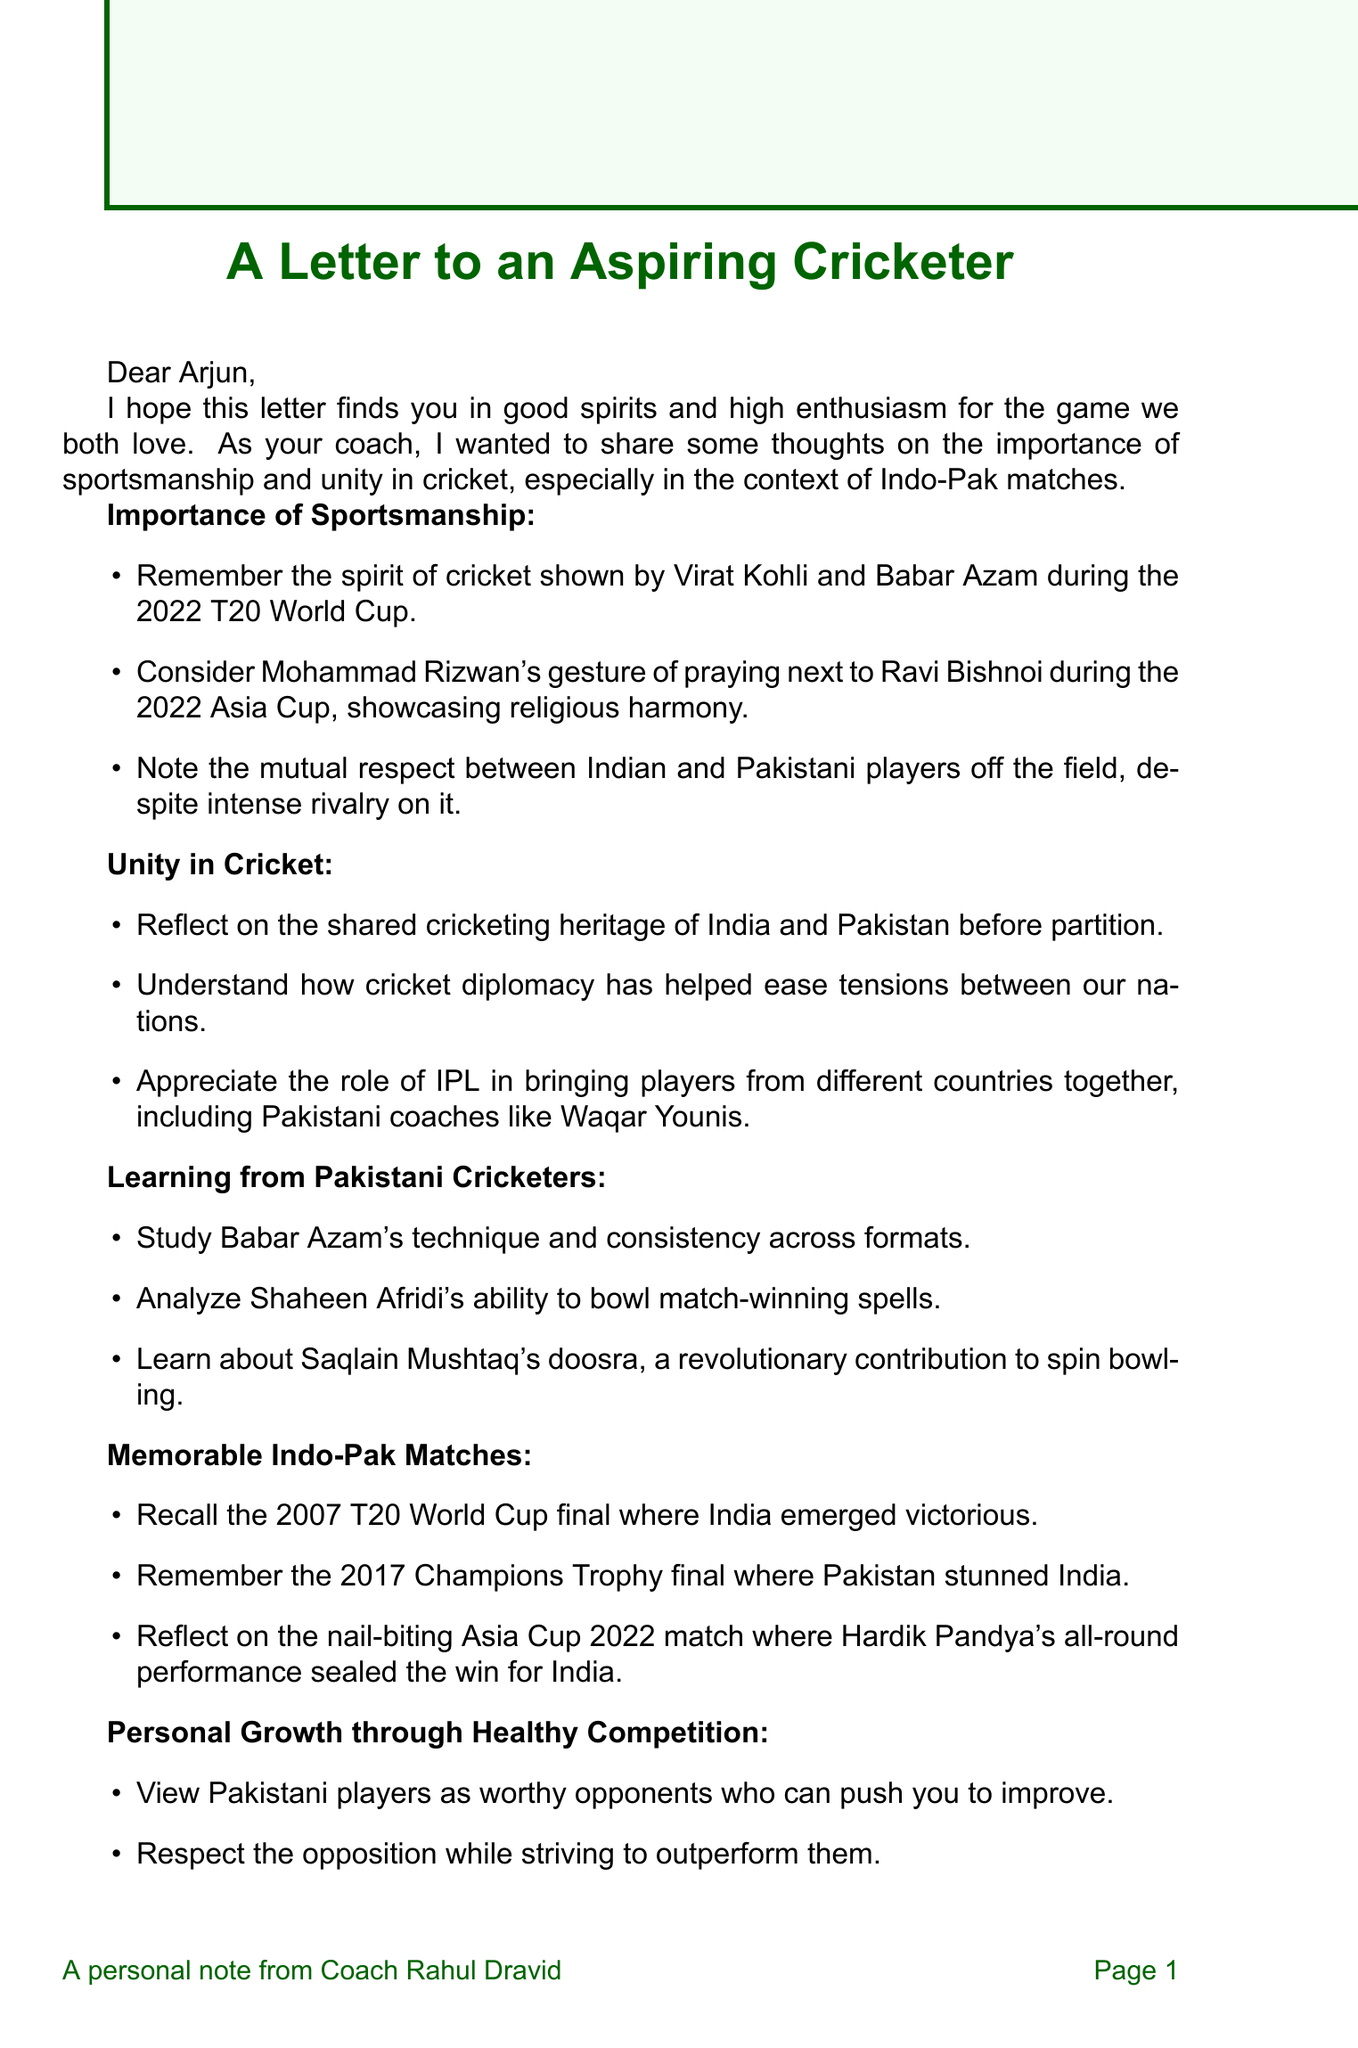What is the name of the coach? The letter identifies the coach as Rahul Dravid, who is addressing the player Arjun.
Answer: Rahul Dravid Who is the recipient of the letter? The letter is specifically addressed to a young cricketer named Arjun, indicating he is the recipient.
Answer: Arjun What year did the T20 World Cup mentioned in the letter take place? The letter references the 2022 T20 World Cup, highlighting its significance in sportsmanship between Indian and Pakistani players.
Answer: 2022 Which Pakistani cricketer's bowling technique is praised in the letter? The letter highlights Shaheen Afridi's ability to bowl match-winning spells, making a note of his impressive skills.
Answer: Shaheen Afridi What event did India win in 2007? The letter recalls the 2007 T20 World Cup final, where India emerged victorious against Pakistan, marking a memorable match.
Answer: T20 World Cup final What does the coach encourage Arjun to embody? The coach urges Arjun to embody the spirit of cricket in all his actions, fostering good sportsmanship and behavior.
Answer: spirit of cricket Which Pakistani coach is mentioned in connection with the IPL? The letter mentions Waqar Younis as a notable Pakistani coach who has been involved in the IPL, promoting unity through cricket.
Answer: Waqar Younis How does the coach suggest Arjun should view Pakistani players? The coach encourages Arjun to view Pakistani players as worthy opponents that can inspire him to improve his own game.
Answer: worthy opponents What gesture did Mohammad Rizwan make during the Asia Cup? The letter cites Mohammad Rizwan's gesture of praying next to Ravi Bishnoi during the 2022 Asia Cup as a significant example of respect and harmony.
Answer: praying next to Ravi Bishnoi 